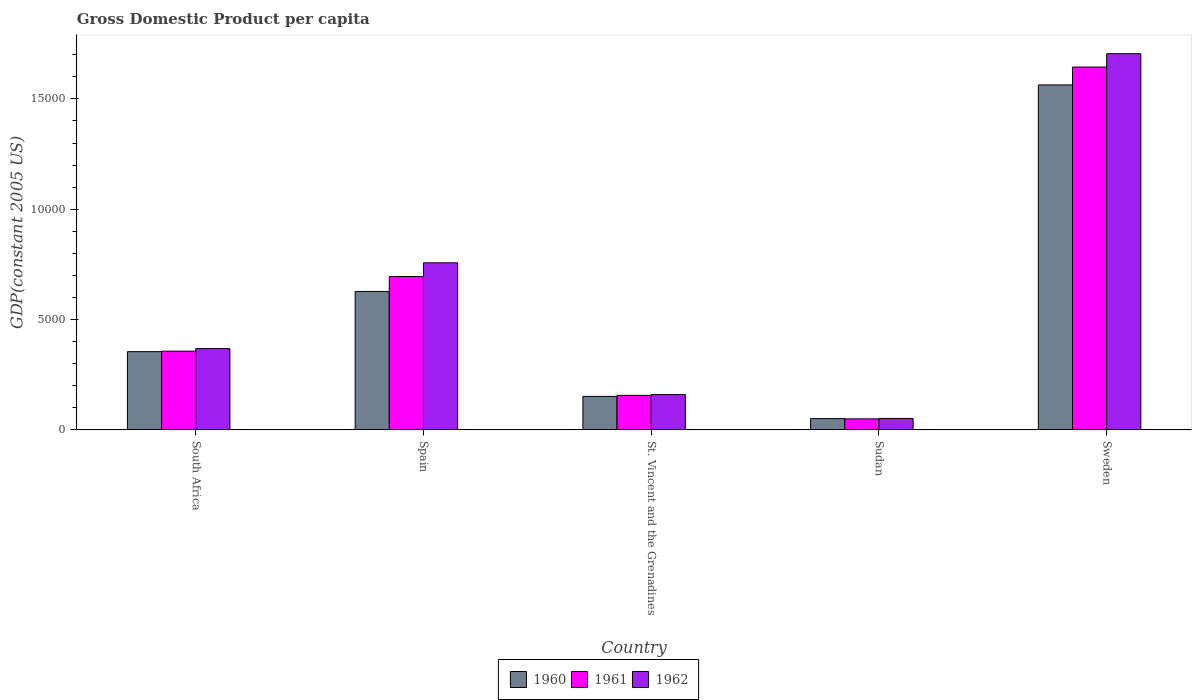How many different coloured bars are there?
Make the answer very short. 3. Are the number of bars on each tick of the X-axis equal?
Keep it short and to the point. Yes. How many bars are there on the 5th tick from the left?
Provide a succinct answer. 3. What is the label of the 1st group of bars from the left?
Your answer should be very brief. South Africa. In how many cases, is the number of bars for a given country not equal to the number of legend labels?
Your response must be concise. 0. What is the GDP per capita in 1962 in South Africa?
Your response must be concise. 3682.01. Across all countries, what is the maximum GDP per capita in 1961?
Your answer should be very brief. 1.64e+04. Across all countries, what is the minimum GDP per capita in 1961?
Make the answer very short. 494.94. In which country was the GDP per capita in 1960 minimum?
Your answer should be compact. Sudan. What is the total GDP per capita in 1960 in the graph?
Keep it short and to the point. 2.75e+04. What is the difference between the GDP per capita in 1961 in Spain and that in St. Vincent and the Grenadines?
Provide a short and direct response. 5388.47. What is the difference between the GDP per capita in 1961 in Sweden and the GDP per capita in 1962 in St. Vincent and the Grenadines?
Provide a succinct answer. 1.48e+04. What is the average GDP per capita in 1962 per country?
Give a very brief answer. 6083.66. What is the difference between the GDP per capita of/in 1960 and GDP per capita of/in 1961 in Sweden?
Give a very brief answer. -810.66. In how many countries, is the GDP per capita in 1960 greater than 14000 US$?
Your response must be concise. 1. What is the ratio of the GDP per capita in 1961 in Spain to that in St. Vincent and the Grenadines?
Keep it short and to the point. 4.45. What is the difference between the highest and the second highest GDP per capita in 1960?
Provide a short and direct response. -1.21e+04. What is the difference between the highest and the lowest GDP per capita in 1961?
Provide a short and direct response. 1.60e+04. In how many countries, is the GDP per capita in 1961 greater than the average GDP per capita in 1961 taken over all countries?
Provide a succinct answer. 2. Is the sum of the GDP per capita in 1960 in Spain and Sudan greater than the maximum GDP per capita in 1962 across all countries?
Your response must be concise. No. What does the 2nd bar from the left in Sweden represents?
Provide a succinct answer. 1961. Is it the case that in every country, the sum of the GDP per capita in 1960 and GDP per capita in 1962 is greater than the GDP per capita in 1961?
Provide a succinct answer. Yes. How many bars are there?
Ensure brevity in your answer.  15. How many countries are there in the graph?
Your answer should be very brief. 5. What is the difference between two consecutive major ticks on the Y-axis?
Your response must be concise. 5000. Does the graph contain grids?
Ensure brevity in your answer.  No. What is the title of the graph?
Make the answer very short. Gross Domestic Product per capita. Does "1960" appear as one of the legend labels in the graph?
Give a very brief answer. Yes. What is the label or title of the Y-axis?
Offer a very short reply. GDP(constant 2005 US). What is the GDP(constant 2005 US) of 1960 in South Africa?
Your answer should be compact. 3543.52. What is the GDP(constant 2005 US) in 1961 in South Africa?
Your answer should be compact. 3566.22. What is the GDP(constant 2005 US) of 1962 in South Africa?
Make the answer very short. 3682.01. What is the GDP(constant 2005 US) in 1960 in Spain?
Provide a short and direct response. 6271.86. What is the GDP(constant 2005 US) in 1961 in Spain?
Keep it short and to the point. 6949.5. What is the GDP(constant 2005 US) in 1962 in Spain?
Ensure brevity in your answer.  7571.23. What is the GDP(constant 2005 US) of 1960 in St. Vincent and the Grenadines?
Offer a terse response. 1515.48. What is the GDP(constant 2005 US) in 1961 in St. Vincent and the Grenadines?
Keep it short and to the point. 1561.03. What is the GDP(constant 2005 US) of 1962 in St. Vincent and the Grenadines?
Provide a short and direct response. 1598.04. What is the GDP(constant 2005 US) of 1960 in Sudan?
Ensure brevity in your answer.  507.97. What is the GDP(constant 2005 US) of 1961 in Sudan?
Give a very brief answer. 494.94. What is the GDP(constant 2005 US) of 1962 in Sudan?
Make the answer very short. 515.24. What is the GDP(constant 2005 US) of 1960 in Sweden?
Offer a very short reply. 1.56e+04. What is the GDP(constant 2005 US) of 1961 in Sweden?
Make the answer very short. 1.64e+04. What is the GDP(constant 2005 US) of 1962 in Sweden?
Offer a very short reply. 1.71e+04. Across all countries, what is the maximum GDP(constant 2005 US) in 1960?
Keep it short and to the point. 1.56e+04. Across all countries, what is the maximum GDP(constant 2005 US) of 1961?
Provide a succinct answer. 1.64e+04. Across all countries, what is the maximum GDP(constant 2005 US) in 1962?
Make the answer very short. 1.71e+04. Across all countries, what is the minimum GDP(constant 2005 US) in 1960?
Give a very brief answer. 507.97. Across all countries, what is the minimum GDP(constant 2005 US) in 1961?
Keep it short and to the point. 494.94. Across all countries, what is the minimum GDP(constant 2005 US) of 1962?
Your response must be concise. 515.24. What is the total GDP(constant 2005 US) of 1960 in the graph?
Provide a short and direct response. 2.75e+04. What is the total GDP(constant 2005 US) in 1961 in the graph?
Provide a short and direct response. 2.90e+04. What is the total GDP(constant 2005 US) in 1962 in the graph?
Make the answer very short. 3.04e+04. What is the difference between the GDP(constant 2005 US) of 1960 in South Africa and that in Spain?
Offer a very short reply. -2728.34. What is the difference between the GDP(constant 2005 US) of 1961 in South Africa and that in Spain?
Offer a very short reply. -3383.28. What is the difference between the GDP(constant 2005 US) of 1962 in South Africa and that in Spain?
Provide a succinct answer. -3889.23. What is the difference between the GDP(constant 2005 US) of 1960 in South Africa and that in St. Vincent and the Grenadines?
Make the answer very short. 2028.04. What is the difference between the GDP(constant 2005 US) in 1961 in South Africa and that in St. Vincent and the Grenadines?
Provide a succinct answer. 2005.19. What is the difference between the GDP(constant 2005 US) in 1962 in South Africa and that in St. Vincent and the Grenadines?
Your response must be concise. 2083.97. What is the difference between the GDP(constant 2005 US) in 1960 in South Africa and that in Sudan?
Ensure brevity in your answer.  3035.55. What is the difference between the GDP(constant 2005 US) in 1961 in South Africa and that in Sudan?
Offer a terse response. 3071.28. What is the difference between the GDP(constant 2005 US) in 1962 in South Africa and that in Sudan?
Your response must be concise. 3166.76. What is the difference between the GDP(constant 2005 US) in 1960 in South Africa and that in Sweden?
Provide a succinct answer. -1.21e+04. What is the difference between the GDP(constant 2005 US) in 1961 in South Africa and that in Sweden?
Make the answer very short. -1.29e+04. What is the difference between the GDP(constant 2005 US) in 1962 in South Africa and that in Sweden?
Provide a short and direct response. -1.34e+04. What is the difference between the GDP(constant 2005 US) of 1960 in Spain and that in St. Vincent and the Grenadines?
Make the answer very short. 4756.38. What is the difference between the GDP(constant 2005 US) in 1961 in Spain and that in St. Vincent and the Grenadines?
Your answer should be very brief. 5388.47. What is the difference between the GDP(constant 2005 US) of 1962 in Spain and that in St. Vincent and the Grenadines?
Your answer should be very brief. 5973.2. What is the difference between the GDP(constant 2005 US) in 1960 in Spain and that in Sudan?
Offer a very short reply. 5763.88. What is the difference between the GDP(constant 2005 US) in 1961 in Spain and that in Sudan?
Offer a very short reply. 6454.56. What is the difference between the GDP(constant 2005 US) in 1962 in Spain and that in Sudan?
Your answer should be compact. 7055.99. What is the difference between the GDP(constant 2005 US) in 1960 in Spain and that in Sweden?
Keep it short and to the point. -9363.18. What is the difference between the GDP(constant 2005 US) in 1961 in Spain and that in Sweden?
Offer a very short reply. -9496.2. What is the difference between the GDP(constant 2005 US) of 1962 in Spain and that in Sweden?
Offer a terse response. -9480.54. What is the difference between the GDP(constant 2005 US) of 1960 in St. Vincent and the Grenadines and that in Sudan?
Ensure brevity in your answer.  1007.51. What is the difference between the GDP(constant 2005 US) in 1961 in St. Vincent and the Grenadines and that in Sudan?
Keep it short and to the point. 1066.09. What is the difference between the GDP(constant 2005 US) of 1962 in St. Vincent and the Grenadines and that in Sudan?
Ensure brevity in your answer.  1082.79. What is the difference between the GDP(constant 2005 US) of 1960 in St. Vincent and the Grenadines and that in Sweden?
Keep it short and to the point. -1.41e+04. What is the difference between the GDP(constant 2005 US) in 1961 in St. Vincent and the Grenadines and that in Sweden?
Give a very brief answer. -1.49e+04. What is the difference between the GDP(constant 2005 US) in 1962 in St. Vincent and the Grenadines and that in Sweden?
Make the answer very short. -1.55e+04. What is the difference between the GDP(constant 2005 US) in 1960 in Sudan and that in Sweden?
Your answer should be compact. -1.51e+04. What is the difference between the GDP(constant 2005 US) in 1961 in Sudan and that in Sweden?
Your answer should be very brief. -1.60e+04. What is the difference between the GDP(constant 2005 US) of 1962 in Sudan and that in Sweden?
Provide a succinct answer. -1.65e+04. What is the difference between the GDP(constant 2005 US) of 1960 in South Africa and the GDP(constant 2005 US) of 1961 in Spain?
Provide a succinct answer. -3405.98. What is the difference between the GDP(constant 2005 US) in 1960 in South Africa and the GDP(constant 2005 US) in 1962 in Spain?
Your response must be concise. -4027.71. What is the difference between the GDP(constant 2005 US) of 1961 in South Africa and the GDP(constant 2005 US) of 1962 in Spain?
Make the answer very short. -4005.01. What is the difference between the GDP(constant 2005 US) in 1960 in South Africa and the GDP(constant 2005 US) in 1961 in St. Vincent and the Grenadines?
Provide a succinct answer. 1982.49. What is the difference between the GDP(constant 2005 US) of 1960 in South Africa and the GDP(constant 2005 US) of 1962 in St. Vincent and the Grenadines?
Your answer should be compact. 1945.48. What is the difference between the GDP(constant 2005 US) in 1961 in South Africa and the GDP(constant 2005 US) in 1962 in St. Vincent and the Grenadines?
Make the answer very short. 1968.18. What is the difference between the GDP(constant 2005 US) in 1960 in South Africa and the GDP(constant 2005 US) in 1961 in Sudan?
Your response must be concise. 3048.58. What is the difference between the GDP(constant 2005 US) in 1960 in South Africa and the GDP(constant 2005 US) in 1962 in Sudan?
Your response must be concise. 3028.28. What is the difference between the GDP(constant 2005 US) in 1961 in South Africa and the GDP(constant 2005 US) in 1962 in Sudan?
Make the answer very short. 3050.98. What is the difference between the GDP(constant 2005 US) of 1960 in South Africa and the GDP(constant 2005 US) of 1961 in Sweden?
Give a very brief answer. -1.29e+04. What is the difference between the GDP(constant 2005 US) of 1960 in South Africa and the GDP(constant 2005 US) of 1962 in Sweden?
Provide a short and direct response. -1.35e+04. What is the difference between the GDP(constant 2005 US) of 1961 in South Africa and the GDP(constant 2005 US) of 1962 in Sweden?
Provide a succinct answer. -1.35e+04. What is the difference between the GDP(constant 2005 US) of 1960 in Spain and the GDP(constant 2005 US) of 1961 in St. Vincent and the Grenadines?
Make the answer very short. 4710.83. What is the difference between the GDP(constant 2005 US) in 1960 in Spain and the GDP(constant 2005 US) in 1962 in St. Vincent and the Grenadines?
Keep it short and to the point. 4673.82. What is the difference between the GDP(constant 2005 US) of 1961 in Spain and the GDP(constant 2005 US) of 1962 in St. Vincent and the Grenadines?
Your answer should be compact. 5351.46. What is the difference between the GDP(constant 2005 US) in 1960 in Spain and the GDP(constant 2005 US) in 1961 in Sudan?
Your answer should be compact. 5776.92. What is the difference between the GDP(constant 2005 US) of 1960 in Spain and the GDP(constant 2005 US) of 1962 in Sudan?
Ensure brevity in your answer.  5756.61. What is the difference between the GDP(constant 2005 US) of 1961 in Spain and the GDP(constant 2005 US) of 1962 in Sudan?
Provide a short and direct response. 6434.26. What is the difference between the GDP(constant 2005 US) in 1960 in Spain and the GDP(constant 2005 US) in 1961 in Sweden?
Provide a succinct answer. -1.02e+04. What is the difference between the GDP(constant 2005 US) of 1960 in Spain and the GDP(constant 2005 US) of 1962 in Sweden?
Offer a very short reply. -1.08e+04. What is the difference between the GDP(constant 2005 US) of 1961 in Spain and the GDP(constant 2005 US) of 1962 in Sweden?
Provide a succinct answer. -1.01e+04. What is the difference between the GDP(constant 2005 US) in 1960 in St. Vincent and the Grenadines and the GDP(constant 2005 US) in 1961 in Sudan?
Provide a short and direct response. 1020.54. What is the difference between the GDP(constant 2005 US) in 1960 in St. Vincent and the Grenadines and the GDP(constant 2005 US) in 1962 in Sudan?
Your answer should be compact. 1000.24. What is the difference between the GDP(constant 2005 US) in 1961 in St. Vincent and the Grenadines and the GDP(constant 2005 US) in 1962 in Sudan?
Your answer should be compact. 1045.78. What is the difference between the GDP(constant 2005 US) in 1960 in St. Vincent and the Grenadines and the GDP(constant 2005 US) in 1961 in Sweden?
Keep it short and to the point. -1.49e+04. What is the difference between the GDP(constant 2005 US) in 1960 in St. Vincent and the Grenadines and the GDP(constant 2005 US) in 1962 in Sweden?
Offer a very short reply. -1.55e+04. What is the difference between the GDP(constant 2005 US) of 1961 in St. Vincent and the Grenadines and the GDP(constant 2005 US) of 1962 in Sweden?
Your answer should be very brief. -1.55e+04. What is the difference between the GDP(constant 2005 US) of 1960 in Sudan and the GDP(constant 2005 US) of 1961 in Sweden?
Keep it short and to the point. -1.59e+04. What is the difference between the GDP(constant 2005 US) in 1960 in Sudan and the GDP(constant 2005 US) in 1962 in Sweden?
Provide a short and direct response. -1.65e+04. What is the difference between the GDP(constant 2005 US) of 1961 in Sudan and the GDP(constant 2005 US) of 1962 in Sweden?
Your response must be concise. -1.66e+04. What is the average GDP(constant 2005 US) of 1960 per country?
Offer a very short reply. 5494.77. What is the average GDP(constant 2005 US) in 1961 per country?
Ensure brevity in your answer.  5803.48. What is the average GDP(constant 2005 US) of 1962 per country?
Your response must be concise. 6083.66. What is the difference between the GDP(constant 2005 US) in 1960 and GDP(constant 2005 US) in 1961 in South Africa?
Offer a very short reply. -22.7. What is the difference between the GDP(constant 2005 US) of 1960 and GDP(constant 2005 US) of 1962 in South Africa?
Offer a very short reply. -138.49. What is the difference between the GDP(constant 2005 US) of 1961 and GDP(constant 2005 US) of 1962 in South Africa?
Keep it short and to the point. -115.79. What is the difference between the GDP(constant 2005 US) of 1960 and GDP(constant 2005 US) of 1961 in Spain?
Offer a very short reply. -677.64. What is the difference between the GDP(constant 2005 US) of 1960 and GDP(constant 2005 US) of 1962 in Spain?
Offer a very short reply. -1299.38. What is the difference between the GDP(constant 2005 US) in 1961 and GDP(constant 2005 US) in 1962 in Spain?
Offer a terse response. -621.73. What is the difference between the GDP(constant 2005 US) of 1960 and GDP(constant 2005 US) of 1961 in St. Vincent and the Grenadines?
Give a very brief answer. -45.55. What is the difference between the GDP(constant 2005 US) in 1960 and GDP(constant 2005 US) in 1962 in St. Vincent and the Grenadines?
Your response must be concise. -82.55. What is the difference between the GDP(constant 2005 US) in 1961 and GDP(constant 2005 US) in 1962 in St. Vincent and the Grenadines?
Provide a succinct answer. -37.01. What is the difference between the GDP(constant 2005 US) of 1960 and GDP(constant 2005 US) of 1961 in Sudan?
Your response must be concise. 13.04. What is the difference between the GDP(constant 2005 US) in 1960 and GDP(constant 2005 US) in 1962 in Sudan?
Your answer should be compact. -7.27. What is the difference between the GDP(constant 2005 US) of 1961 and GDP(constant 2005 US) of 1962 in Sudan?
Give a very brief answer. -20.31. What is the difference between the GDP(constant 2005 US) of 1960 and GDP(constant 2005 US) of 1961 in Sweden?
Your answer should be very brief. -810.66. What is the difference between the GDP(constant 2005 US) in 1960 and GDP(constant 2005 US) in 1962 in Sweden?
Offer a very short reply. -1416.73. What is the difference between the GDP(constant 2005 US) in 1961 and GDP(constant 2005 US) in 1962 in Sweden?
Your response must be concise. -606.08. What is the ratio of the GDP(constant 2005 US) of 1960 in South Africa to that in Spain?
Give a very brief answer. 0.56. What is the ratio of the GDP(constant 2005 US) of 1961 in South Africa to that in Spain?
Give a very brief answer. 0.51. What is the ratio of the GDP(constant 2005 US) in 1962 in South Africa to that in Spain?
Give a very brief answer. 0.49. What is the ratio of the GDP(constant 2005 US) in 1960 in South Africa to that in St. Vincent and the Grenadines?
Ensure brevity in your answer.  2.34. What is the ratio of the GDP(constant 2005 US) of 1961 in South Africa to that in St. Vincent and the Grenadines?
Your answer should be very brief. 2.28. What is the ratio of the GDP(constant 2005 US) of 1962 in South Africa to that in St. Vincent and the Grenadines?
Offer a very short reply. 2.3. What is the ratio of the GDP(constant 2005 US) of 1960 in South Africa to that in Sudan?
Ensure brevity in your answer.  6.98. What is the ratio of the GDP(constant 2005 US) in 1961 in South Africa to that in Sudan?
Your response must be concise. 7.21. What is the ratio of the GDP(constant 2005 US) in 1962 in South Africa to that in Sudan?
Offer a very short reply. 7.15. What is the ratio of the GDP(constant 2005 US) of 1960 in South Africa to that in Sweden?
Offer a terse response. 0.23. What is the ratio of the GDP(constant 2005 US) of 1961 in South Africa to that in Sweden?
Provide a succinct answer. 0.22. What is the ratio of the GDP(constant 2005 US) of 1962 in South Africa to that in Sweden?
Your response must be concise. 0.22. What is the ratio of the GDP(constant 2005 US) in 1960 in Spain to that in St. Vincent and the Grenadines?
Offer a terse response. 4.14. What is the ratio of the GDP(constant 2005 US) of 1961 in Spain to that in St. Vincent and the Grenadines?
Offer a terse response. 4.45. What is the ratio of the GDP(constant 2005 US) in 1962 in Spain to that in St. Vincent and the Grenadines?
Provide a succinct answer. 4.74. What is the ratio of the GDP(constant 2005 US) in 1960 in Spain to that in Sudan?
Give a very brief answer. 12.35. What is the ratio of the GDP(constant 2005 US) in 1961 in Spain to that in Sudan?
Keep it short and to the point. 14.04. What is the ratio of the GDP(constant 2005 US) of 1962 in Spain to that in Sudan?
Offer a very short reply. 14.69. What is the ratio of the GDP(constant 2005 US) in 1960 in Spain to that in Sweden?
Ensure brevity in your answer.  0.4. What is the ratio of the GDP(constant 2005 US) in 1961 in Spain to that in Sweden?
Your answer should be very brief. 0.42. What is the ratio of the GDP(constant 2005 US) of 1962 in Spain to that in Sweden?
Give a very brief answer. 0.44. What is the ratio of the GDP(constant 2005 US) in 1960 in St. Vincent and the Grenadines to that in Sudan?
Offer a very short reply. 2.98. What is the ratio of the GDP(constant 2005 US) in 1961 in St. Vincent and the Grenadines to that in Sudan?
Ensure brevity in your answer.  3.15. What is the ratio of the GDP(constant 2005 US) in 1962 in St. Vincent and the Grenadines to that in Sudan?
Offer a terse response. 3.1. What is the ratio of the GDP(constant 2005 US) in 1960 in St. Vincent and the Grenadines to that in Sweden?
Provide a succinct answer. 0.1. What is the ratio of the GDP(constant 2005 US) of 1961 in St. Vincent and the Grenadines to that in Sweden?
Ensure brevity in your answer.  0.09. What is the ratio of the GDP(constant 2005 US) of 1962 in St. Vincent and the Grenadines to that in Sweden?
Your answer should be compact. 0.09. What is the ratio of the GDP(constant 2005 US) in 1960 in Sudan to that in Sweden?
Offer a very short reply. 0.03. What is the ratio of the GDP(constant 2005 US) in 1961 in Sudan to that in Sweden?
Offer a terse response. 0.03. What is the ratio of the GDP(constant 2005 US) of 1962 in Sudan to that in Sweden?
Ensure brevity in your answer.  0.03. What is the difference between the highest and the second highest GDP(constant 2005 US) in 1960?
Your response must be concise. 9363.18. What is the difference between the highest and the second highest GDP(constant 2005 US) of 1961?
Provide a short and direct response. 9496.2. What is the difference between the highest and the second highest GDP(constant 2005 US) of 1962?
Offer a terse response. 9480.54. What is the difference between the highest and the lowest GDP(constant 2005 US) of 1960?
Keep it short and to the point. 1.51e+04. What is the difference between the highest and the lowest GDP(constant 2005 US) in 1961?
Your answer should be very brief. 1.60e+04. What is the difference between the highest and the lowest GDP(constant 2005 US) in 1962?
Your answer should be very brief. 1.65e+04. 